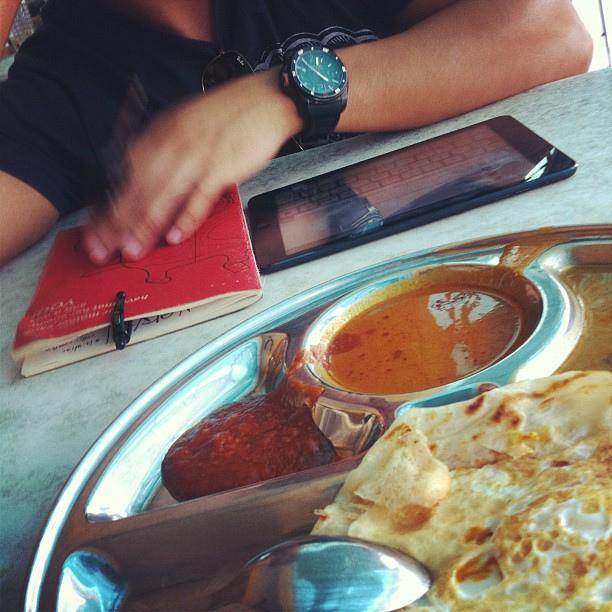What is the silver plate the man is using made of? Please explain your reasoning. metal. The platter is shiny and reflective.  it is silver in color. 